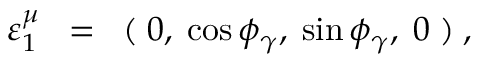<formula> <loc_0><loc_0><loc_500><loc_500>\varepsilon _ { 1 } ^ { \mu } \, = \, ( \, 0 , \, \cos \phi _ { \gamma } , \, \sin \phi _ { \gamma } , \, 0 \, ) \, ,</formula> 